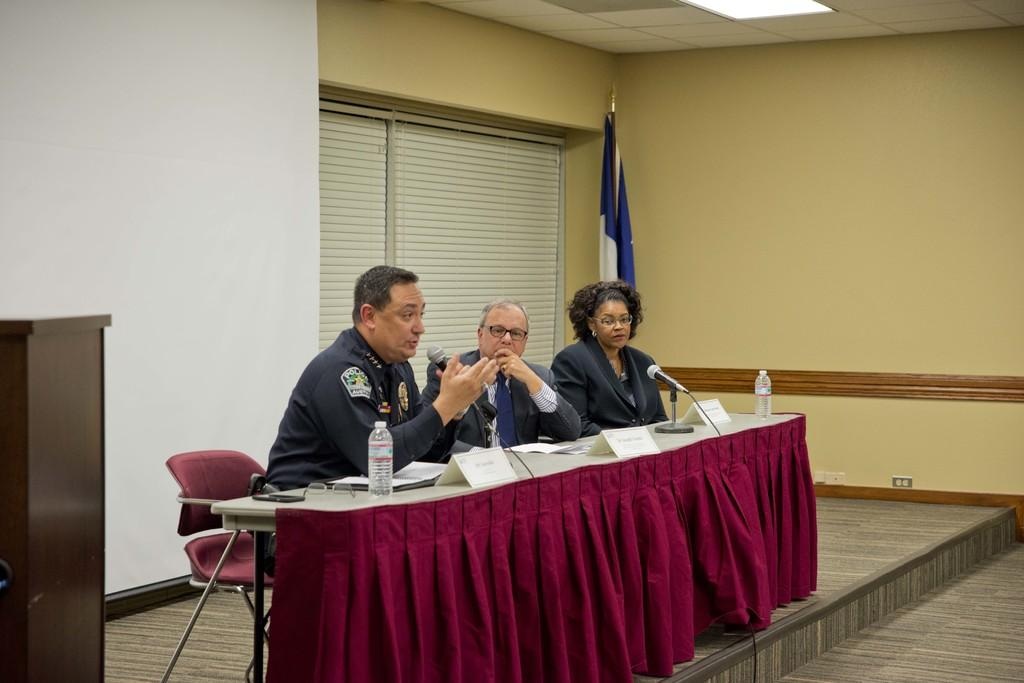What is the occupation of the person in the image? The person in the image is wearing a police uniform, indicating they are a police officer. What is the person in the police uniform doing in the image? The person is sitting and speaking in front of a mic. Are there any other people present in the image? Yes, there are two other persons sitting beside the person in the police uniform. What can be seen in the background of the image? There is a flag in the background of the image. What type of balloon is floating in the background of the image? There is no balloon present in the image; it only features a person in a police uniform, two other persons, and a flag in the background. 